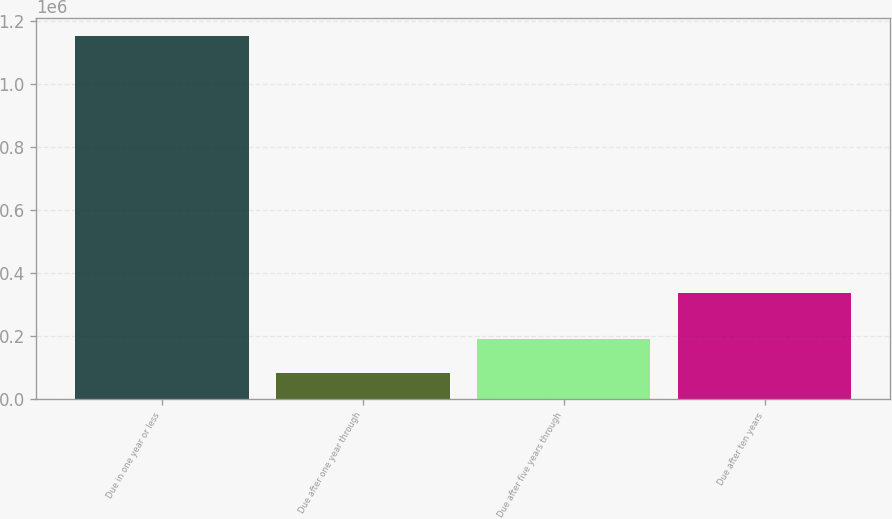<chart> <loc_0><loc_0><loc_500><loc_500><bar_chart><fcel>Due in one year or less<fcel>Due after one year through<fcel>Due after five years through<fcel>Due after ten years<nl><fcel>1.15277e+06<fcel>83674<fcel>190583<fcel>336871<nl></chart> 